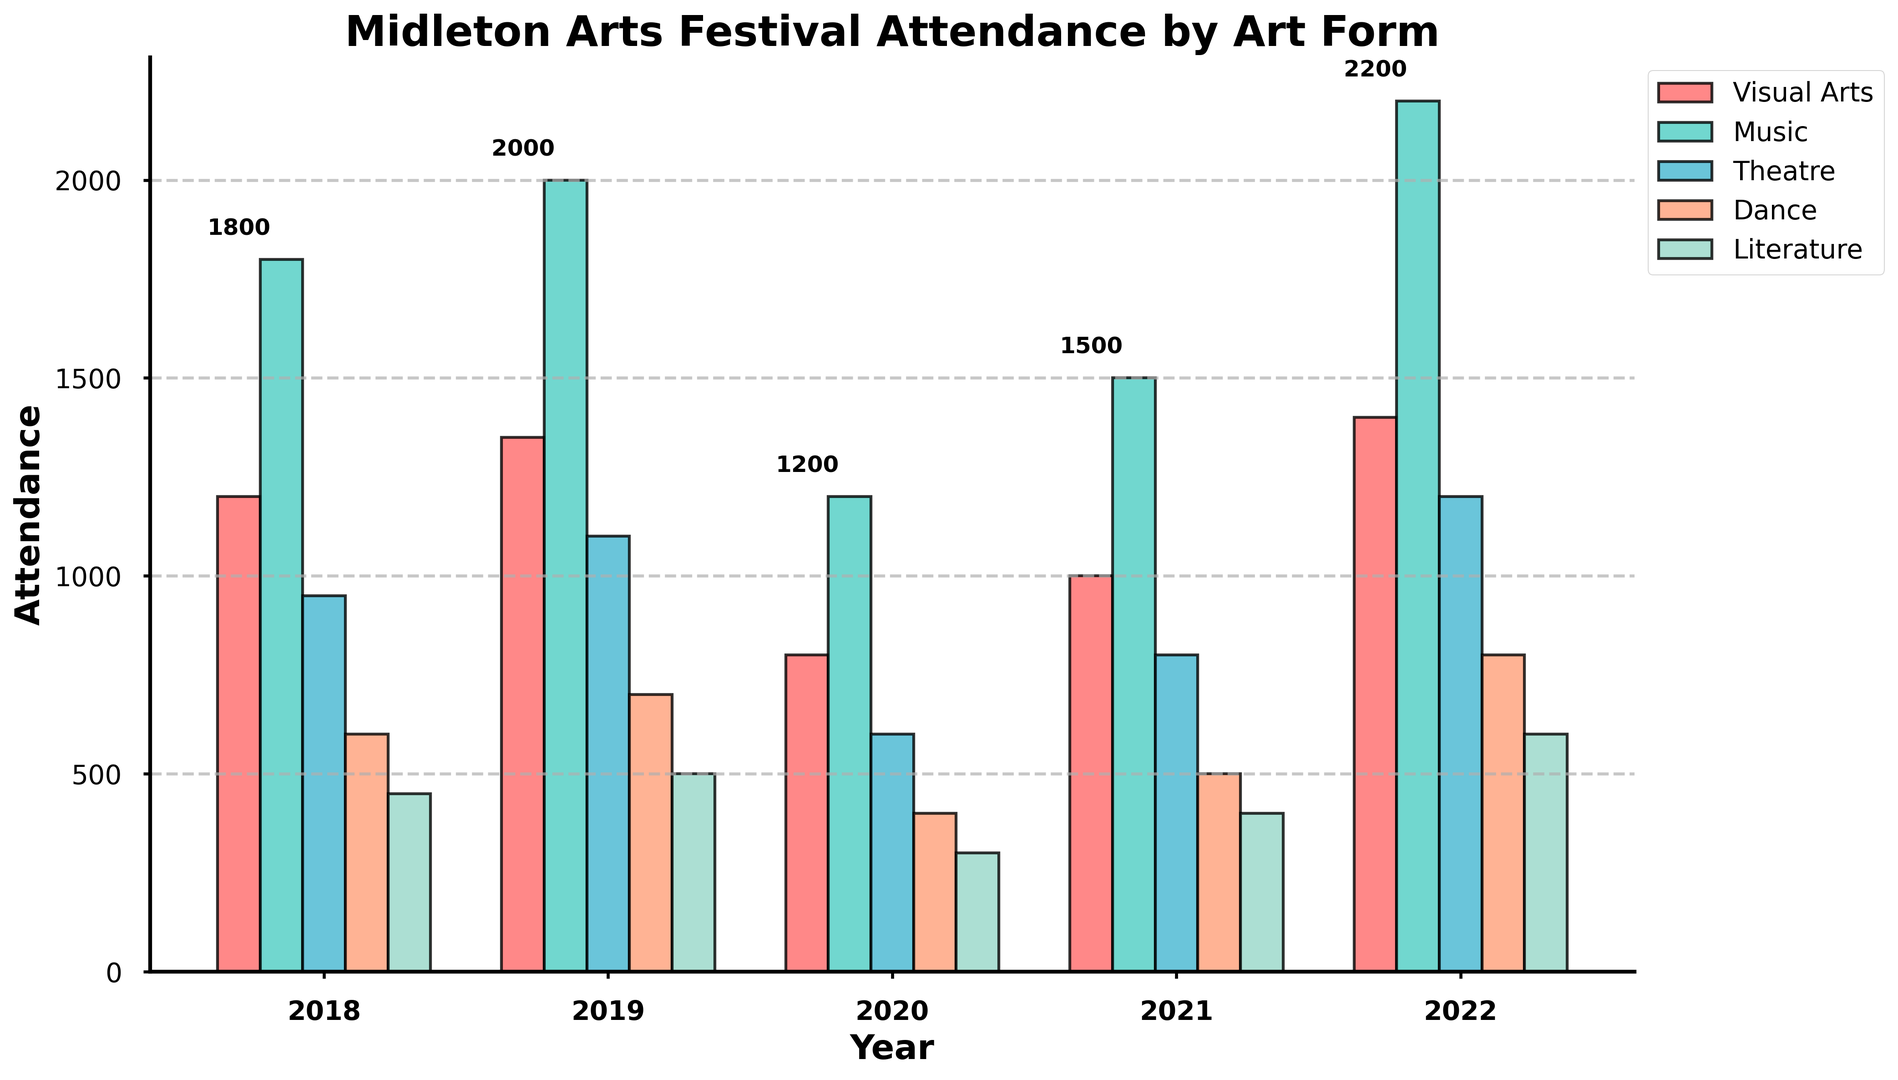Which year had the highest overall attendance across all art forms? Sum the attendance figures for each art form for each year. 2018: 1200 + 1800 + 950 + 600 + 450 = 5000, 2019: 1350 + 2000 + 1100 + 700 + 500 = 5650, 2020: 800 + 1200 + 600 + 400 + 300 = 3300, 2021: 1000 + 1500 + 800 + 500 + 400 = 4200, 2022: 1400 + 2200 + 1200 + 800 + 600 = 6200. 2022 has the highest overall attendance.
Answer: 2022 Which art form had the lowest attendance in 2020? Look at the 2020 attendance numbers for each art form: Visual Arts: 800, Music: 1200, Theatre: 600, Dance: 400, Literature: 300. Literature has the lowest attendance.
Answer: Literature How did music attendance change from 2020 to 2022? Subtract the music attendance in 2020 from the music attendance in 2022. 2022: 2200 - 2020: 1200 = 1000. Music attendance increased by 1000.
Answer: Increased by 1000 What was the most attended art form in 2019? Compare the attendance numbers for each art form in 2019: Visual Arts: 1350, Music: 2000, Theatre: 1100, Dance: 700, Literature: 500. Music had the highest attendance.
Answer: Music Which year had the lowest attendance for Theatre, and what was the attendance figure? Compare the Theatre attendance figures across all years: 2018: 950, 2019: 1100, 2020: 600, 2021: 800, 2022: 1200. The lowest attendance for Theatre was in 2020, at 600.
Answer: 2020, 600 Between which years did Visual Arts attendance increase the most? Calculate the change in Visual Arts attendance between consecutive years: 2018-2019: 1350 - 1200 = 150, 2019-2020: 800 - 1350 = -550, 2020-2021: 1000 - 800 = 200, 2021-2022: 1400 - 1000 = 400. The largest increase is between 2021 and 2022.
Answer: 2021-2022 What was the average attendance of Dance over the 5 years? Sum the attendance figures for Dance over the 5 years and divide by 5. (600 + 700 + 400 + 500 + 800) / 5 = 3000 / 5 = 600. The average attendance is 600.
Answer: 600 Which art form had a consistent increase in attendance every year except 2020? Compare the attendance figures for each art form across the years: Visual Arts: (Yes, 2020 decrease), Music: (Yes, 2020 decrease), Theatre: (Yes, 2020 decrease), Dance: (Yes, 2020 decrease), Literature: (Yes, 2020 decrease). None of the art forms increased consistently every year except in 2020.
Answer: None How much more attendance did Music have than Literature in 2022? Subtract the attendance for Literature from the attendance for Music in 2022. 2200 - 600 = 1600. Music had 1600 more attendees than Literature.
Answer: 1600 Which art form saw a decrease in attendance in 2020 compared to 2019? Compare the attendance figures for each art form in 2019 and 2020. Visual Arts: 1350 to 800 (decrease), Music: 2000 to 1200 (decrease), Theatre: 1100 to 600 (decrease), Dance: 700 to 400 (decrease), Literature: 500 to 300 (decrease). All art forms saw a decrease.
Answer: All 